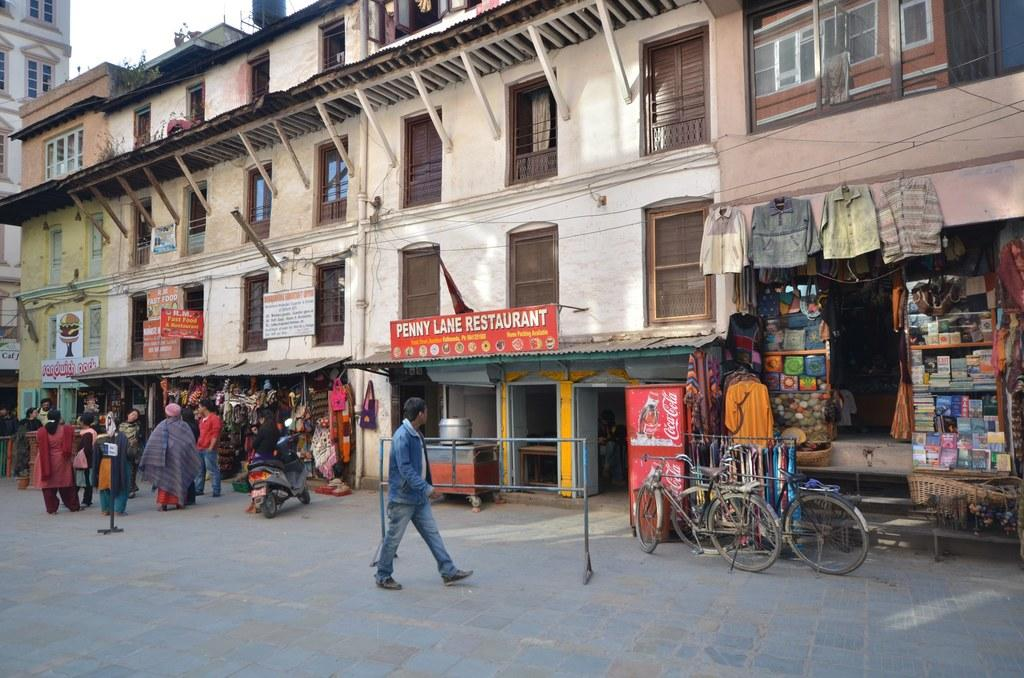<image>
Relay a brief, clear account of the picture shown. Penny Lane Restaurant sits near a market area 